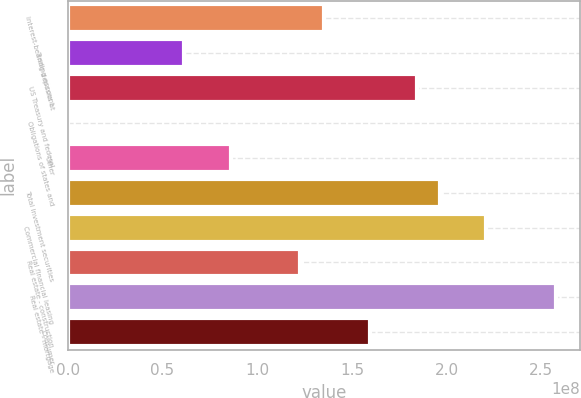Convert chart to OTSL. <chart><loc_0><loc_0><loc_500><loc_500><bar_chart><fcel>Interest-bearing deposits at<fcel>Trading account<fcel>US Treasury and federal<fcel>Obligations of states and<fcel>Other<fcel>Total investment securities<fcel>Commercial financial leasing<fcel>Real estate - construction<fcel>Real estate - mortgage<fcel>Consumer<nl><fcel>1.35054e+08<fcel>6.14562e+07<fcel>1.8412e+08<fcel>124459<fcel>8.59889e+07<fcel>1.96386e+08<fcel>2.20919e+08<fcel>1.22788e+08<fcel>2.57718e+08<fcel>1.59587e+08<nl></chart> 